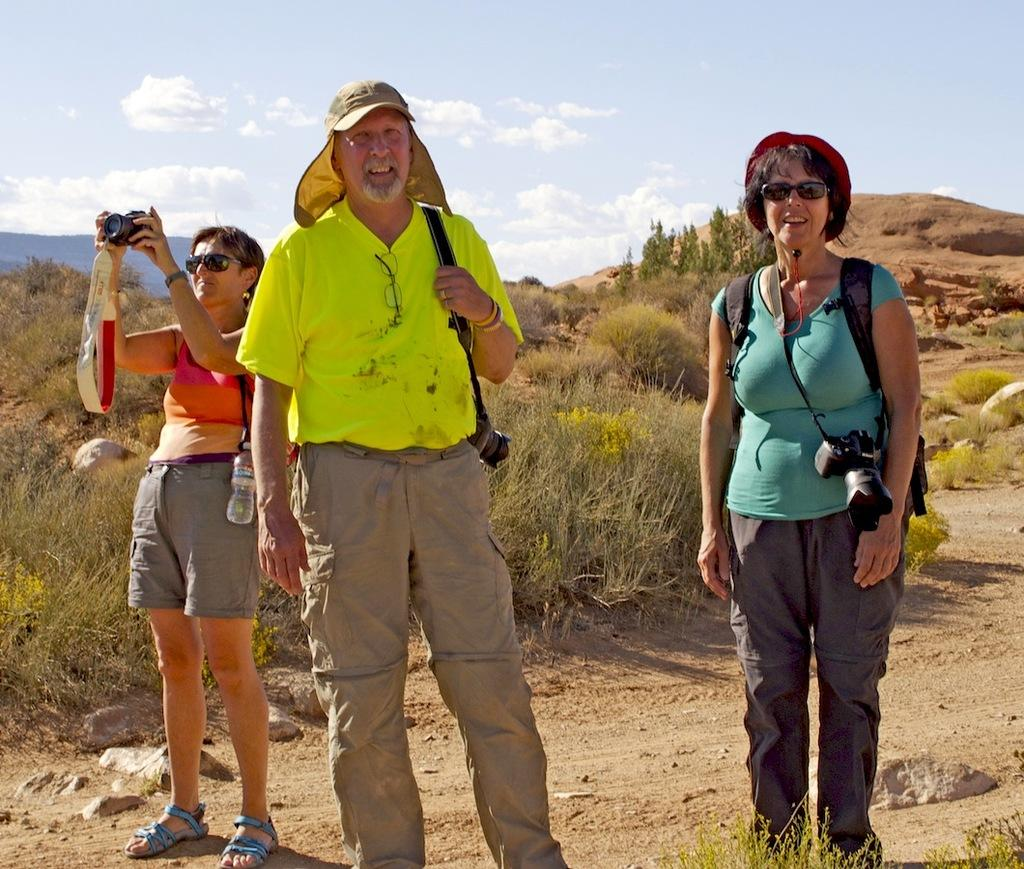How many people are in the image? There are three persons standing on the ground. What is one person doing in the image? One person is holding a camera. What can be seen in the background of the image? There are plants, trees, and the sky visible in the background. What is the condition of the sky in the image? Clouds are present in the sky. What type of beam is being used by the person holding the camera in the image? There is no beam present in the image; the person is simply holding a camera. What sound can be heard coming from the trees in the image? There is no sound present in the image, as it is a still photograph. 